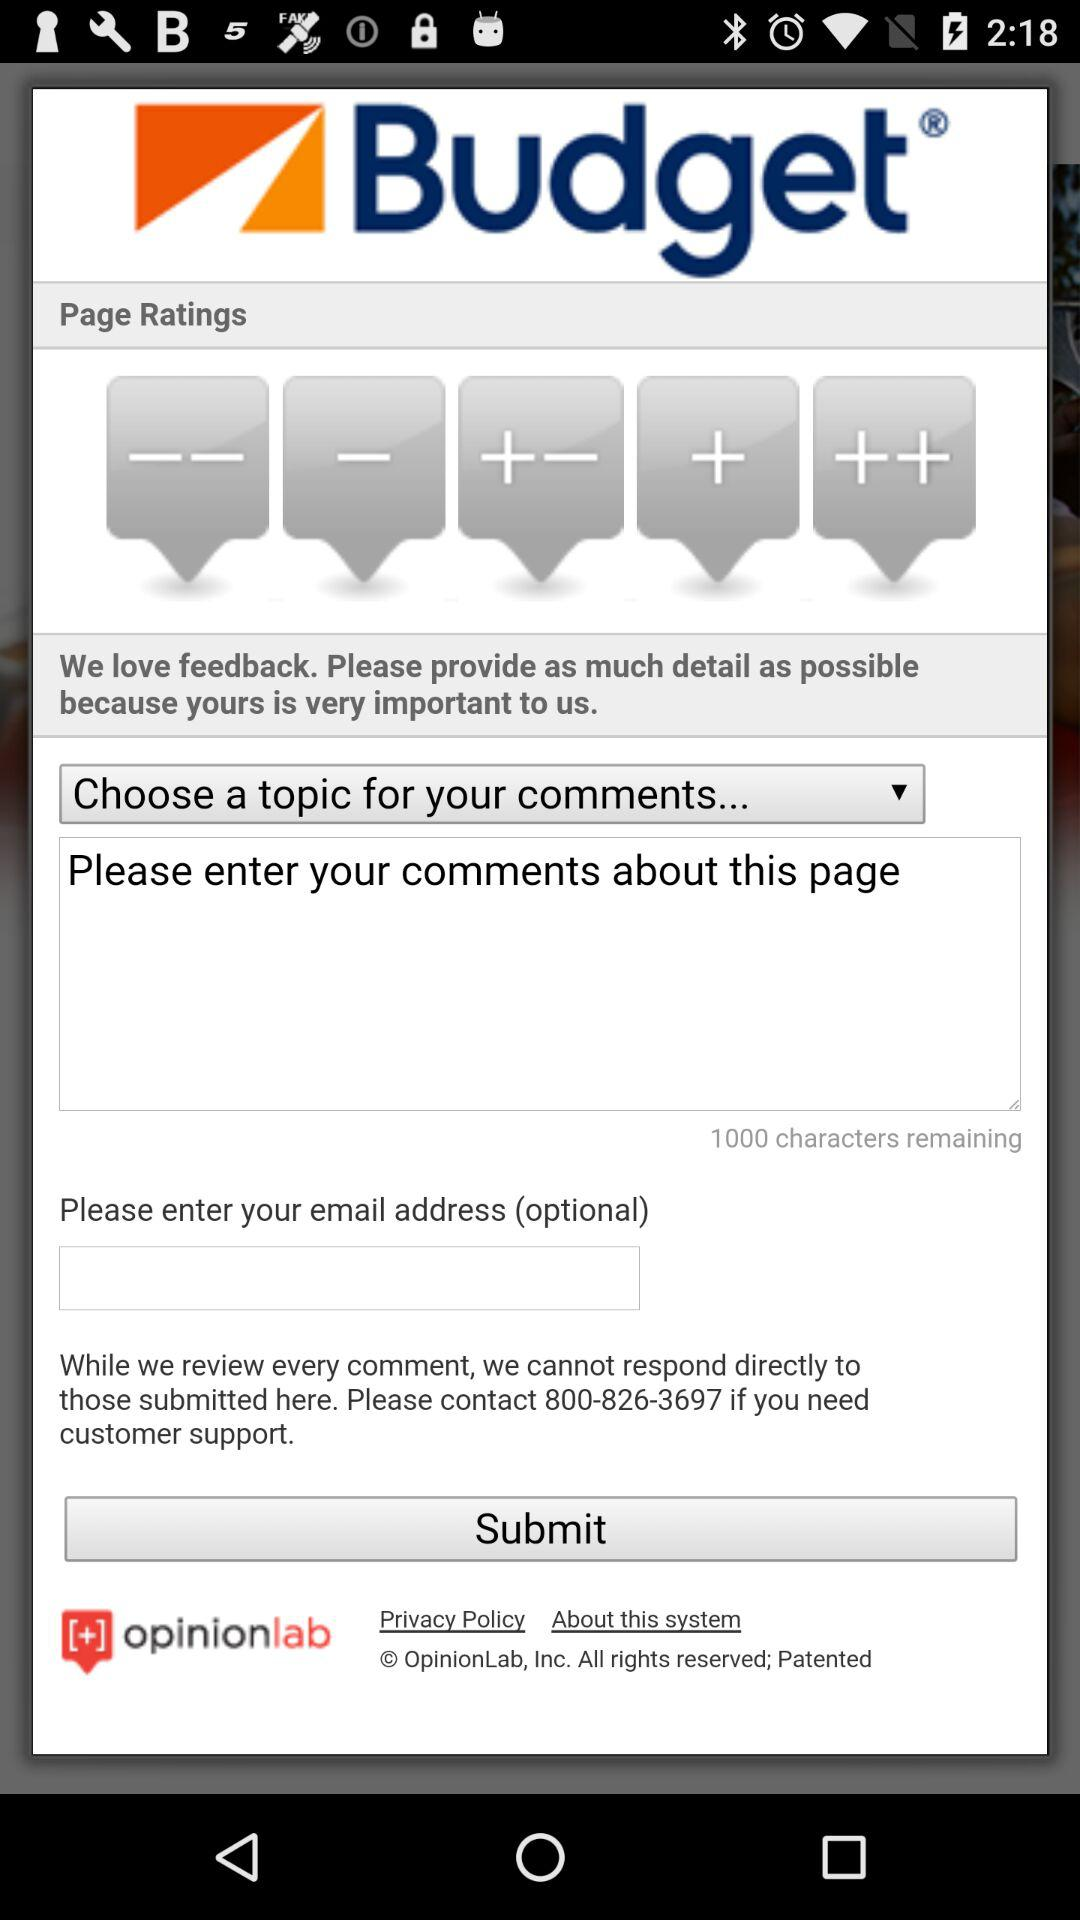What's the contact number for customer support? The contact number is 800-826-3697. 